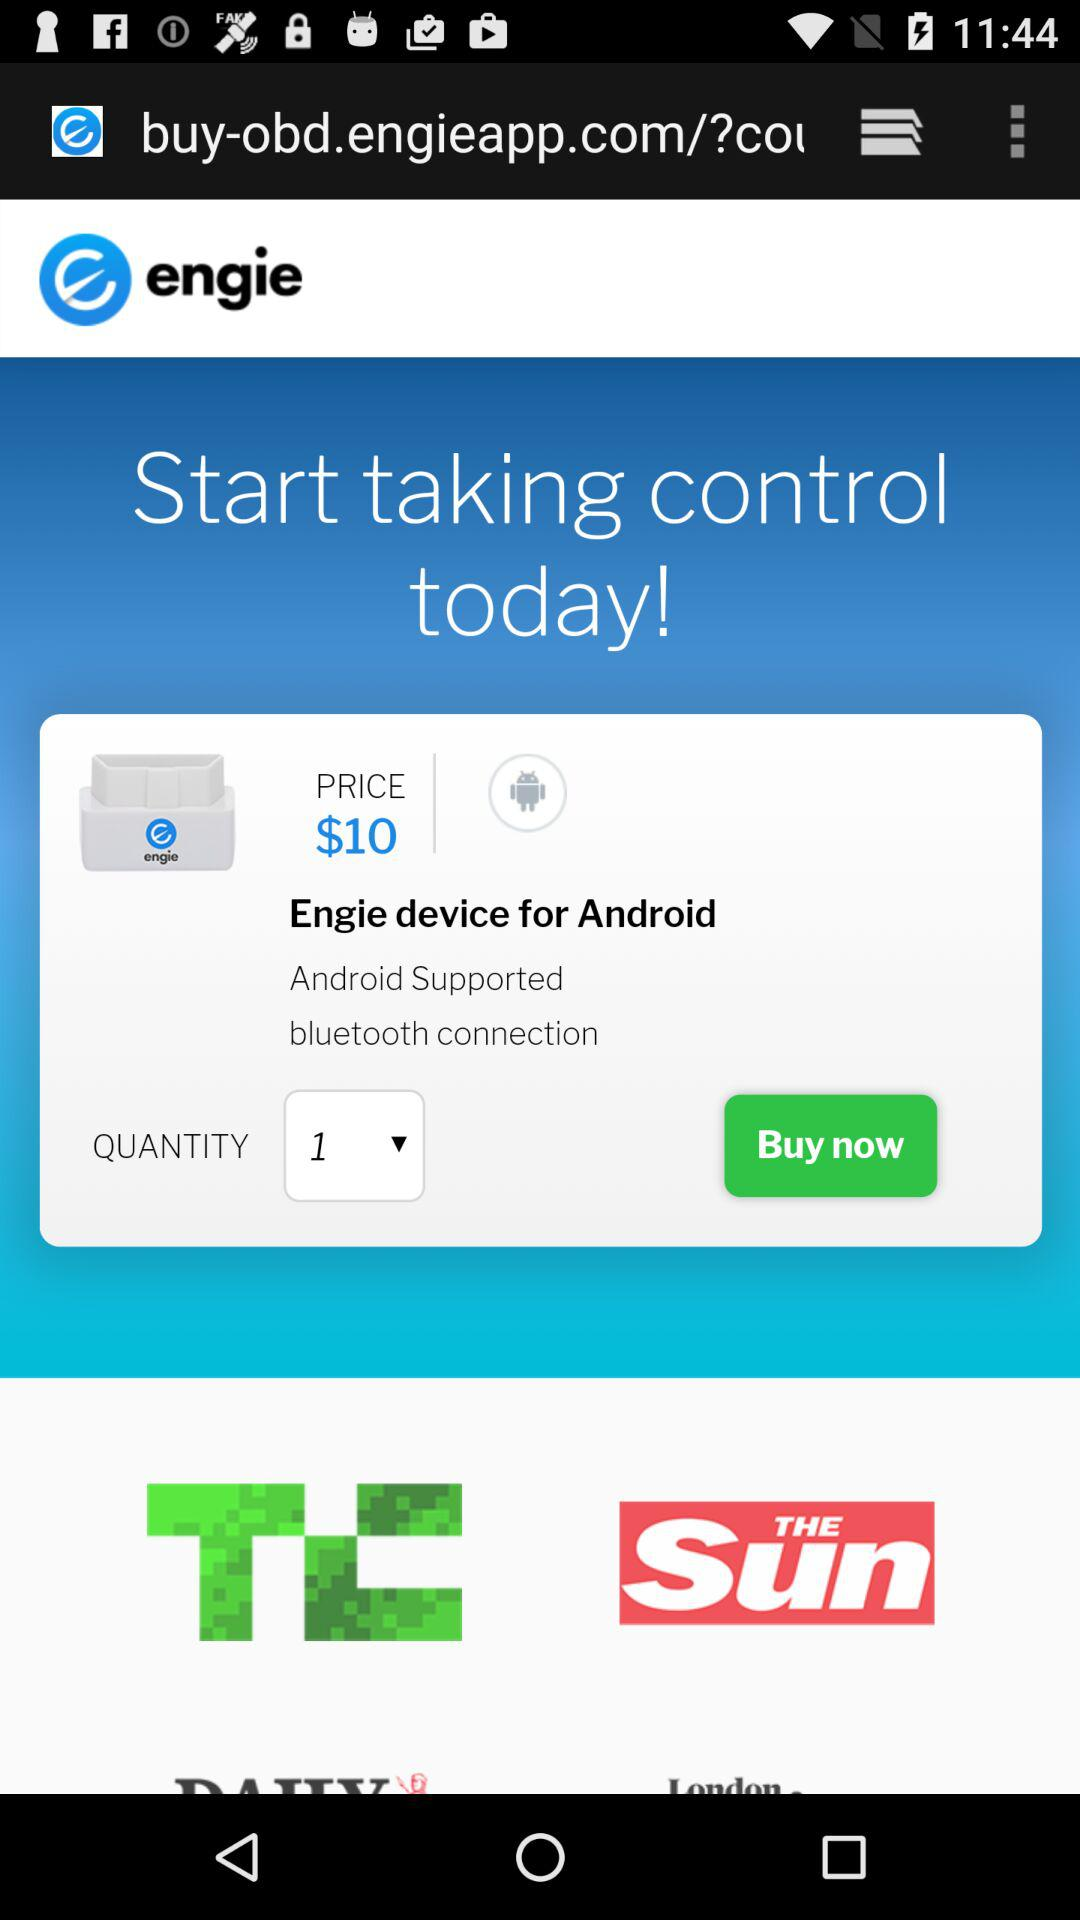What's the price? The price is $10. 